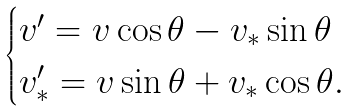Convert formula to latex. <formula><loc_0><loc_0><loc_500><loc_500>\begin{cases} v ^ { \prime } = v \cos \theta - v _ { * } \sin \theta \\ v _ { * } ^ { \prime } = v \sin \theta + v _ { * } \cos \theta . \end{cases}</formula> 